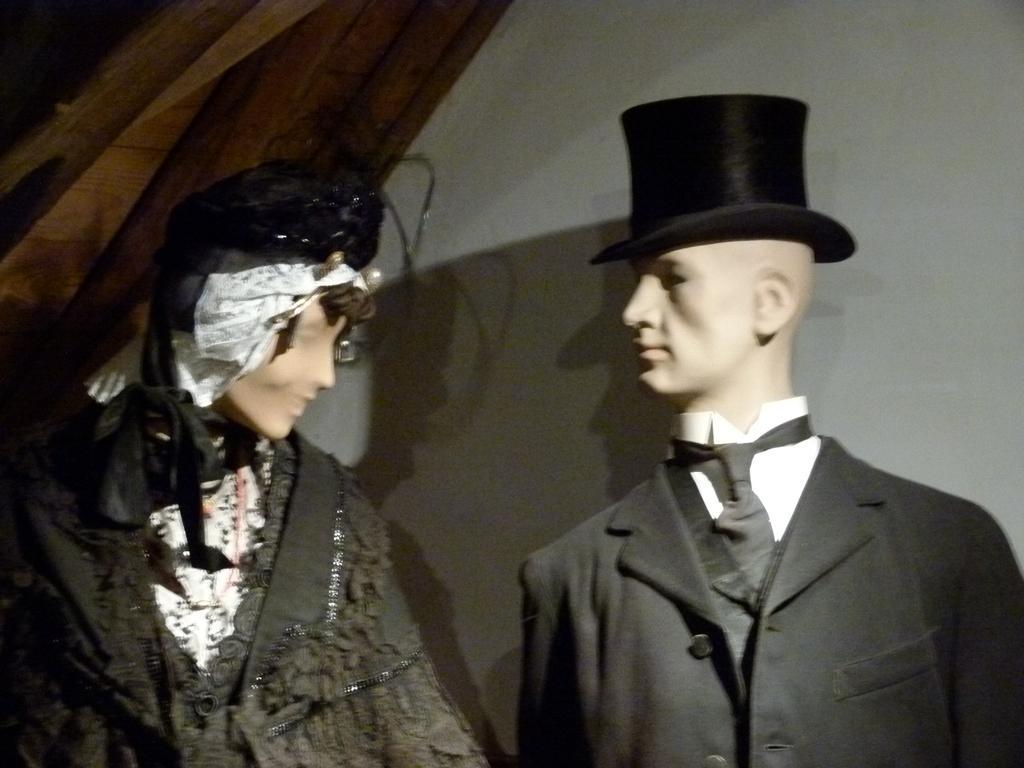Could you give a brief overview of what you see in this image? In this image there is a mannequin of a man and a woman. In the background of the image there is a wall. 